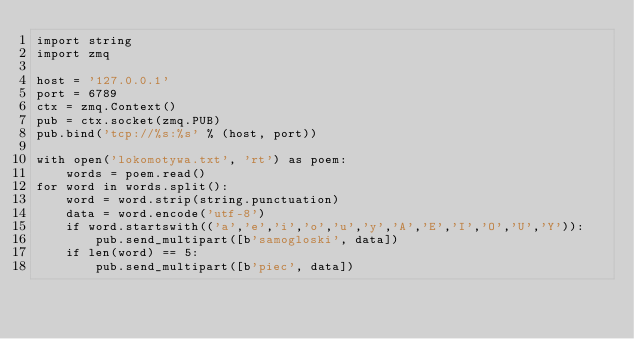<code> <loc_0><loc_0><loc_500><loc_500><_Python_>import string
import zmq

host = '127.0.0.1'
port = 6789
ctx = zmq.Context()
pub = ctx.socket(zmq.PUB)
pub.bind('tcp://%s:%s' % (host, port))

with open('lokomotywa.txt', 'rt') as poem:
    words = poem.read()
for word in words.split():
    word = word.strip(string.punctuation)
    data = word.encode('utf-8')
    if word.startswith(('a','e','i','o','u','y','A','E','I','O','U','Y')):
        pub.send_multipart([b'samogloski', data])
    if len(word) == 5:
        pub.send_multipart([b'piec', data])
</code> 